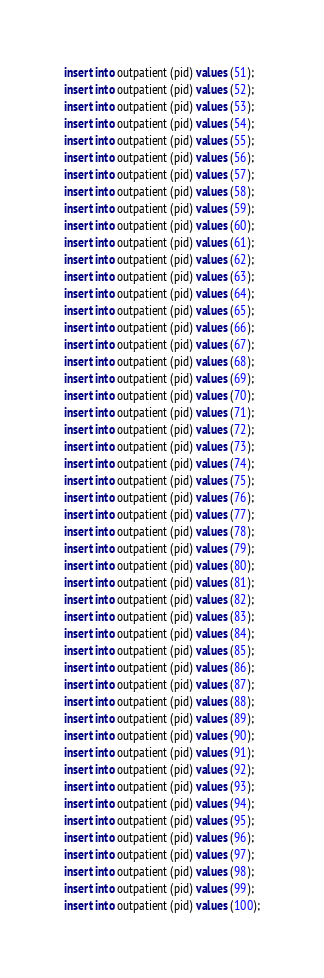Convert code to text. <code><loc_0><loc_0><loc_500><loc_500><_SQL_>insert into outpatient (pid) values (51);
insert into outpatient (pid) values (52);
insert into outpatient (pid) values (53);
insert into outpatient (pid) values (54);
insert into outpatient (pid) values (55);
insert into outpatient (pid) values (56);
insert into outpatient (pid) values (57);
insert into outpatient (pid) values (58);
insert into outpatient (pid) values (59);
insert into outpatient (pid) values (60);
insert into outpatient (pid) values (61);
insert into outpatient (pid) values (62);
insert into outpatient (pid) values (63);
insert into outpatient (pid) values (64);
insert into outpatient (pid) values (65);
insert into outpatient (pid) values (66);
insert into outpatient (pid) values (67);
insert into outpatient (pid) values (68);
insert into outpatient (pid) values (69);
insert into outpatient (pid) values (70);
insert into outpatient (pid) values (71);
insert into outpatient (pid) values (72);
insert into outpatient (pid) values (73);
insert into outpatient (pid) values (74);
insert into outpatient (pid) values (75);
insert into outpatient (pid) values (76);
insert into outpatient (pid) values (77);
insert into outpatient (pid) values (78);
insert into outpatient (pid) values (79);
insert into outpatient (pid) values (80);
insert into outpatient (pid) values (81);
insert into outpatient (pid) values (82);
insert into outpatient (pid) values (83);
insert into outpatient (pid) values (84);
insert into outpatient (pid) values (85);
insert into outpatient (pid) values (86);
insert into outpatient (pid) values (87);
insert into outpatient (pid) values (88);
insert into outpatient (pid) values (89);
insert into outpatient (pid) values (90);
insert into outpatient (pid) values (91);
insert into outpatient (pid) values (92);
insert into outpatient (pid) values (93);
insert into outpatient (pid) values (94);
insert into outpatient (pid) values (95);
insert into outpatient (pid) values (96);
insert into outpatient (pid) values (97);
insert into outpatient (pid) values (98);
insert into outpatient (pid) values (99);
insert into outpatient (pid) values (100);
</code> 